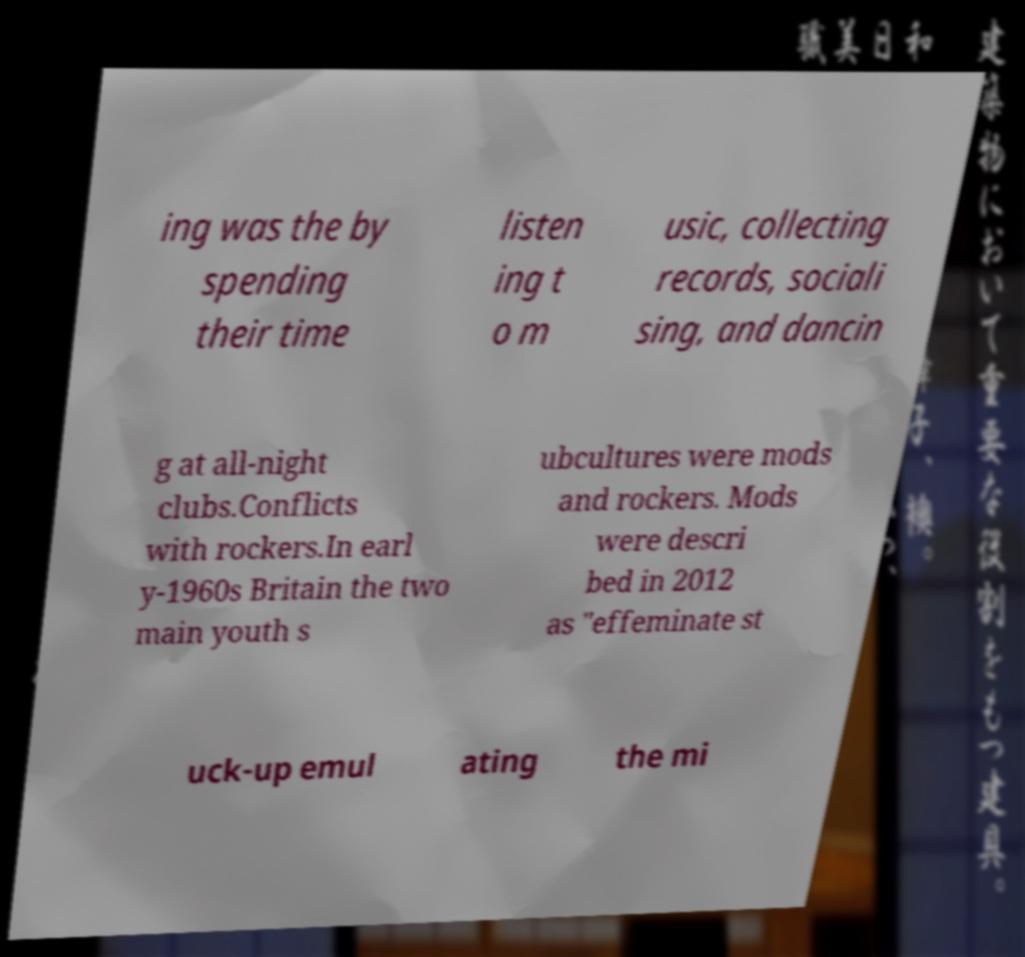Please read and relay the text visible in this image. What does it say? ing was the by spending their time listen ing t o m usic, collecting records, sociali sing, and dancin g at all-night clubs.Conflicts with rockers.In earl y-1960s Britain the two main youth s ubcultures were mods and rockers. Mods were descri bed in 2012 as "effeminate st uck-up emul ating the mi 